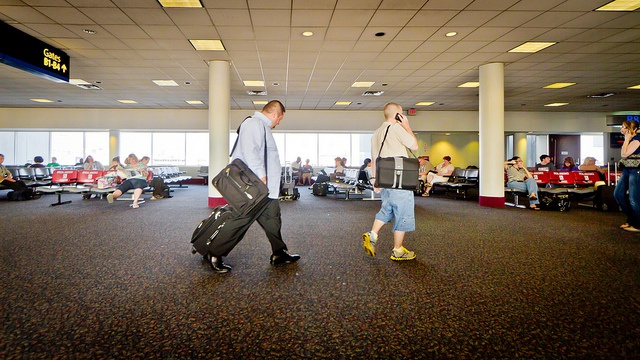Describe the objects in this image and their specific colors. I can see people in olive, lightgray, tan, and darkgray tones, people in olive, lightgray, black, gray, and darkgray tones, handbag in olive, gray, lightgray, black, and darkgray tones, people in olive, white, black, gray, and darkgray tones, and people in olive, black, tan, navy, and blue tones in this image. 